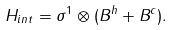Convert formula to latex. <formula><loc_0><loc_0><loc_500><loc_500>H _ { i n t } = \sigma ^ { 1 } \otimes ( B ^ { h } + B ^ { c } ) .</formula> 